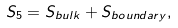<formula> <loc_0><loc_0><loc_500><loc_500>S _ { 5 } = S _ { b u l k } + S _ { b o u n d a r y } ,</formula> 